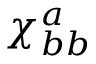<formula> <loc_0><loc_0><loc_500><loc_500>\chi _ { b b } ^ { a }</formula> 